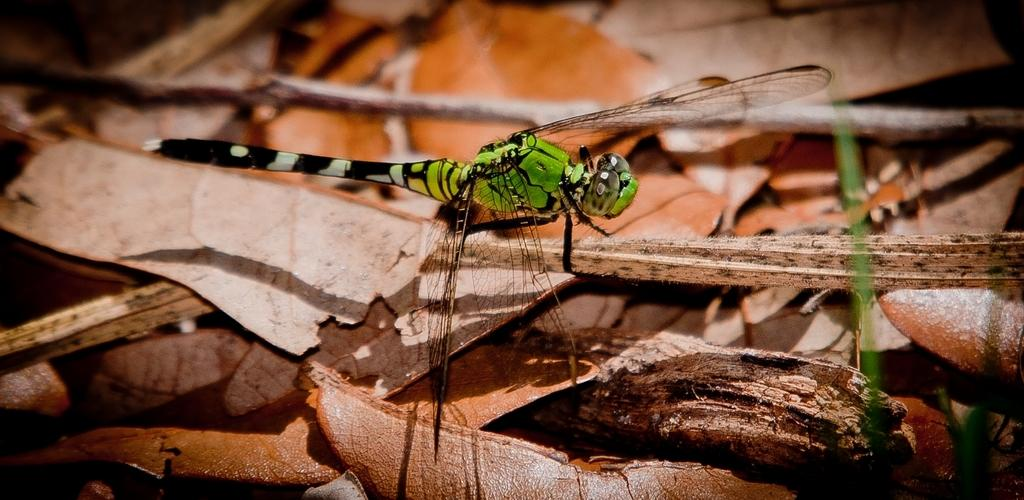What type of creature is in the image? There is an insect in the image. What colors can be seen on the insect? The insect has green, black, and white coloring. What is the insect resting on in the image? The insect is on a brown-colored object. What type of vegetation is present in the image? There are brown-colored leaves in the image. How does the insect run away from the grandfather in the image? There is no grandfather present in the image, and the insect is not running away. 